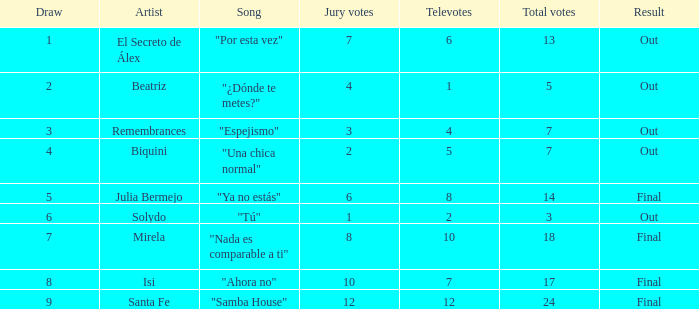Identify the count of tracks for solydo. 1.0. 